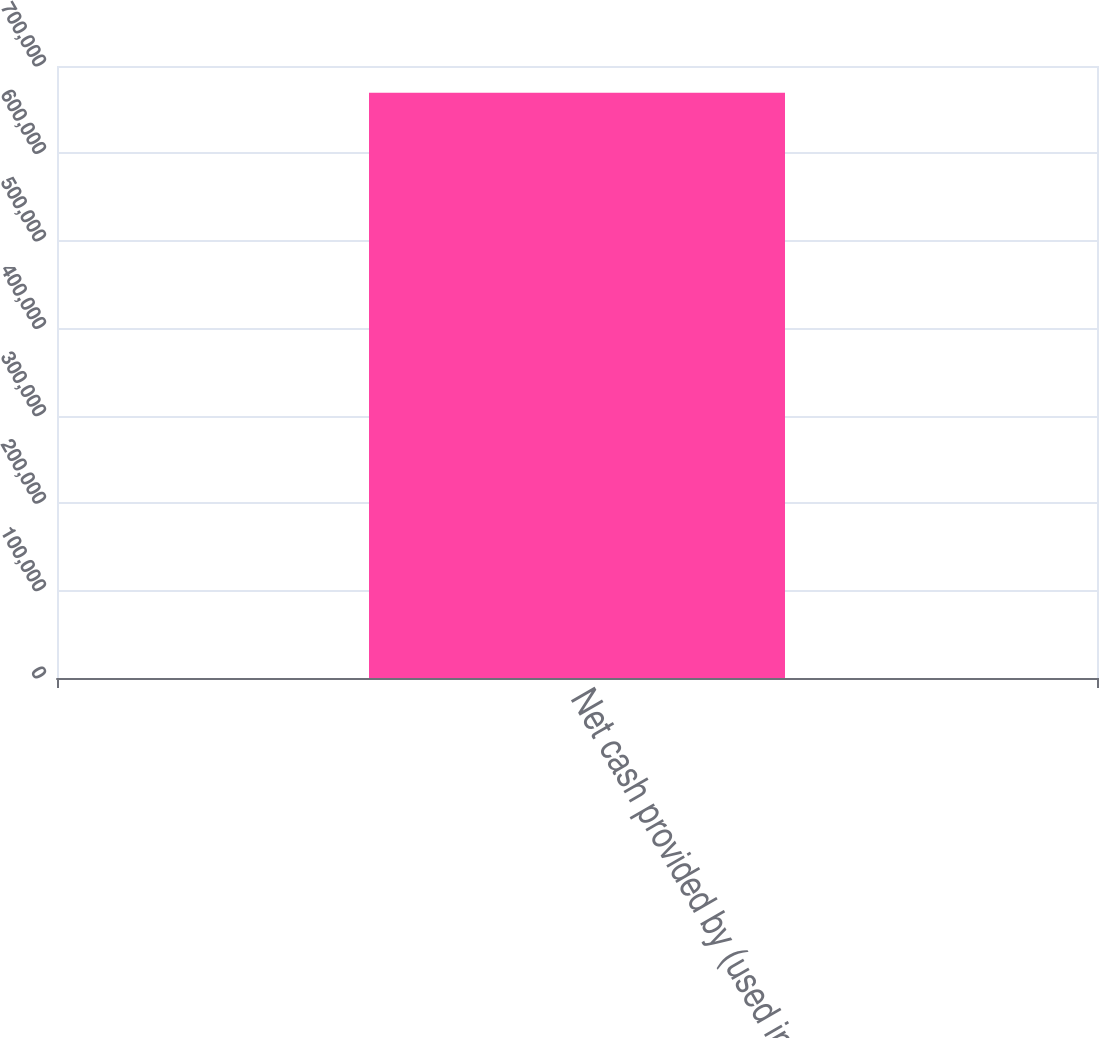Convert chart. <chart><loc_0><loc_0><loc_500><loc_500><bar_chart><fcel>Net cash provided by (used in)<nl><fcel>669500<nl></chart> 